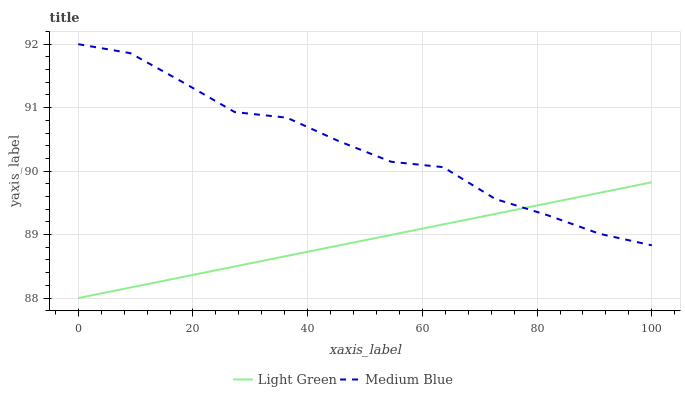Does Light Green have the minimum area under the curve?
Answer yes or no. Yes. Does Medium Blue have the maximum area under the curve?
Answer yes or no. Yes. Does Light Green have the maximum area under the curve?
Answer yes or no. No. Is Light Green the smoothest?
Answer yes or no. Yes. Is Medium Blue the roughest?
Answer yes or no. Yes. Is Light Green the roughest?
Answer yes or no. No. Does Light Green have the lowest value?
Answer yes or no. Yes. Does Medium Blue have the highest value?
Answer yes or no. Yes. Does Light Green have the highest value?
Answer yes or no. No. Does Light Green intersect Medium Blue?
Answer yes or no. Yes. Is Light Green less than Medium Blue?
Answer yes or no. No. Is Light Green greater than Medium Blue?
Answer yes or no. No. 